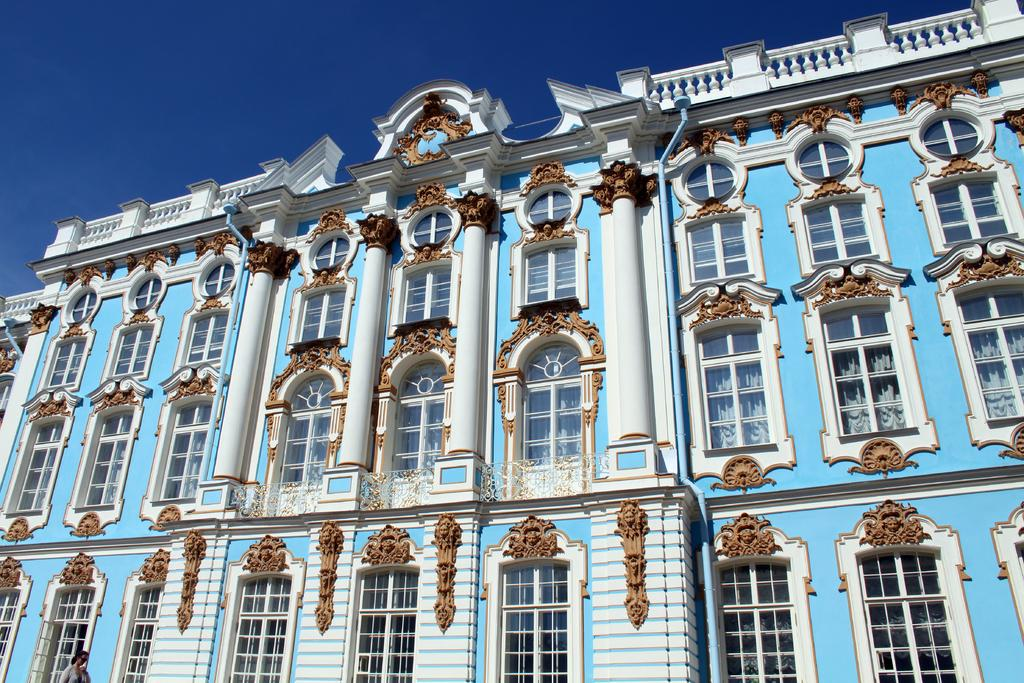What type of structure is present in the image? There is a building in the image. What colors can be seen on the building? The building has white and brown colors. What is visible in the background of the image? The sky is visible in the background of the image. What color is the sky in the image? The sky is blue in color. What is the name of the deer standing next to the building in the image? There is no deer present in the image; it only features a building and the blue sky in the background. 